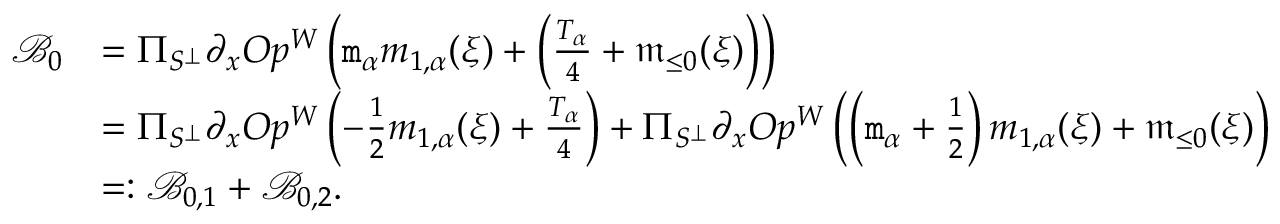<formula> <loc_0><loc_0><loc_500><loc_500>\begin{array} { r l } { \mathcal { B } _ { 0 } } & { = \Pi _ { S ^ { \perp } } \partial _ { x } O p ^ { W } \left ( m _ { \alpha } m _ { 1 , \alpha } ( \xi ) + \left ( \frac { T _ { \alpha } } 4 + \mathfrak { m } _ { \leq 0 } ( \xi ) \right ) \right ) } \\ & { = \Pi _ { S ^ { \perp } } \partial _ { x } O p ^ { W } \left ( - \frac { 1 } { 2 } m _ { 1 , \alpha } ( \xi ) + \frac { T _ { \alpha } } 4 \right ) + \Pi _ { S ^ { \perp } } \partial _ { x } O p ^ { W } \left ( \left ( m _ { \alpha } + \frac { 1 } { 2 } \right ) m _ { 1 , \alpha } ( \xi ) + \mathfrak { m } _ { \leq 0 } ( \xi ) \right ) } \\ & { = \colon \mathcal { B } _ { 0 , 1 } + \mathcal { B } _ { 0 , 2 } . } \end{array}</formula> 